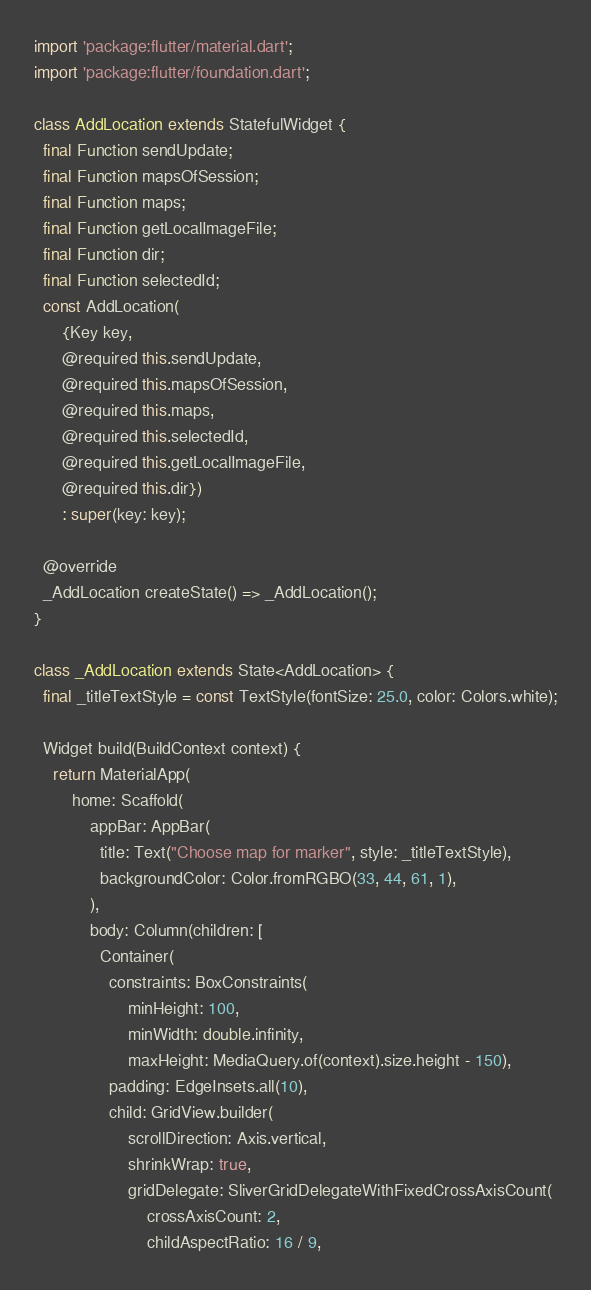Convert code to text. <code><loc_0><loc_0><loc_500><loc_500><_Dart_>import 'package:flutter/material.dart';
import 'package:flutter/foundation.dart';

class AddLocation extends StatefulWidget {
  final Function sendUpdate;
  final Function mapsOfSession;
  final Function maps;
  final Function getLocalImageFile;
  final Function dir;
  final Function selectedId;
  const AddLocation(
      {Key key,
      @required this.sendUpdate,
      @required this.mapsOfSession,
      @required this.maps,
      @required this.selectedId,
      @required this.getLocalImageFile,
      @required this.dir})
      : super(key: key);

  @override
  _AddLocation createState() => _AddLocation();
}

class _AddLocation extends State<AddLocation> {
  final _titleTextStyle = const TextStyle(fontSize: 25.0, color: Colors.white);

  Widget build(BuildContext context) {
    return MaterialApp(
        home: Scaffold(
            appBar: AppBar(
              title: Text("Choose map for marker", style: _titleTextStyle),
              backgroundColor: Color.fromRGBO(33, 44, 61, 1),
            ),
            body: Column(children: [
              Container(
                constraints: BoxConstraints(
                    minHeight: 100,
                    minWidth: double.infinity,
                    maxHeight: MediaQuery.of(context).size.height - 150),
                padding: EdgeInsets.all(10),
                child: GridView.builder(
                    scrollDirection: Axis.vertical,
                    shrinkWrap: true,
                    gridDelegate: SliverGridDelegateWithFixedCrossAxisCount(
                        crossAxisCount: 2,
                        childAspectRatio: 16 / 9,</code> 